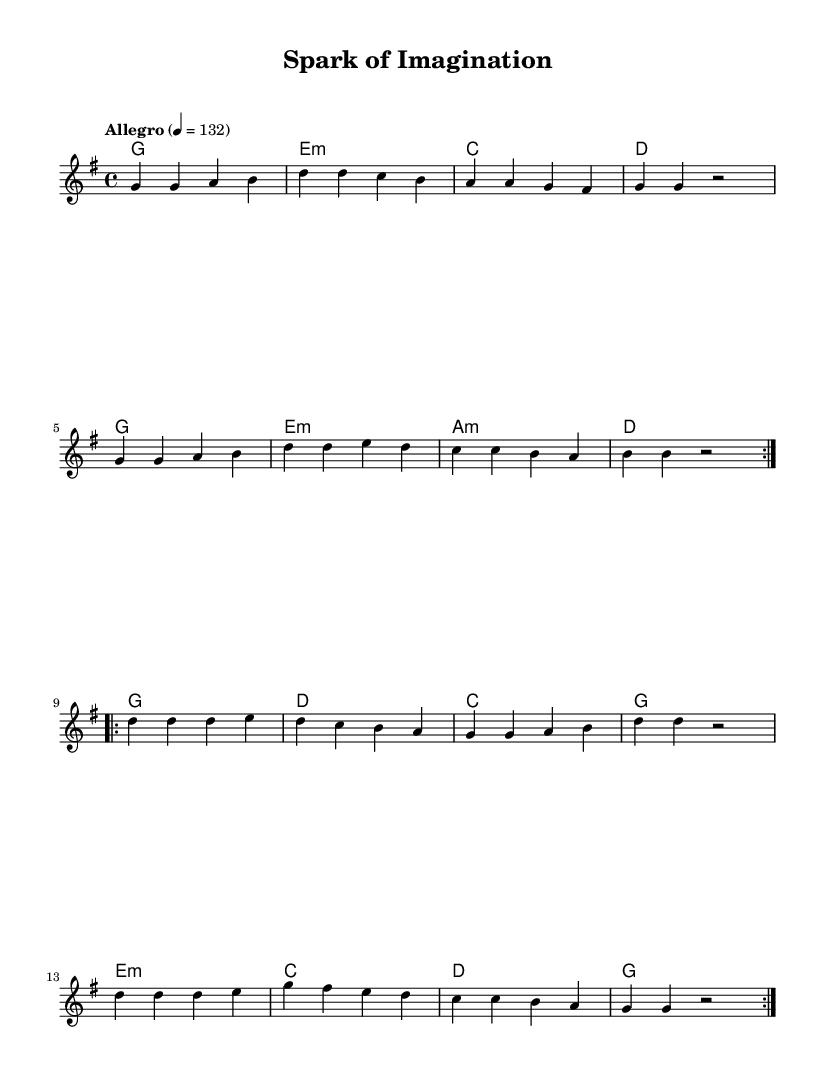What is the key signature of this music? The key signature is G major, indicated by the presence of one sharp (F#). In the sheet music, the key signature is typically found at the beginning, right after the clef symbol.
Answer: G major What is the time signature of this music? The time signature shown in the sheet music is 4/4, which means there are four beats in each measure and the quarter note gets one beat. This is typically indicated at the beginning after the key signature.
Answer: 4/4 What is the tempo marking for this piece? The tempo marking is "Allegro," which signifies a lively and fast pace. It is indicated in the sheet music near the beginning of the score, providing performance instructions.
Answer: Allegro How many measures are in the first section of the melody? The first section of the melody consists of 8 measures. This can be counted by looking at the bar lines that separate the measures in the staff.
Answer: 8 What is the chord of the second measure? The chord in the second measure is E minor. This is identified by the chord symbols present above the staff, which indicate the harmony played during that measure.
Answer: E minor What is the last note of the melody before a repeat? The last note before the repeat in the melody is a quarter rest. This can be observed in the notation at the end of the segment, specifically where a rest is indicated.
Answer: Rest How many different chords are used throughout the piece? There are 8 different chords used throughout the piece, as listed in the chord changes written above the melody. This includes various major and minor chords that create the harmonic structure.
Answer: 8 